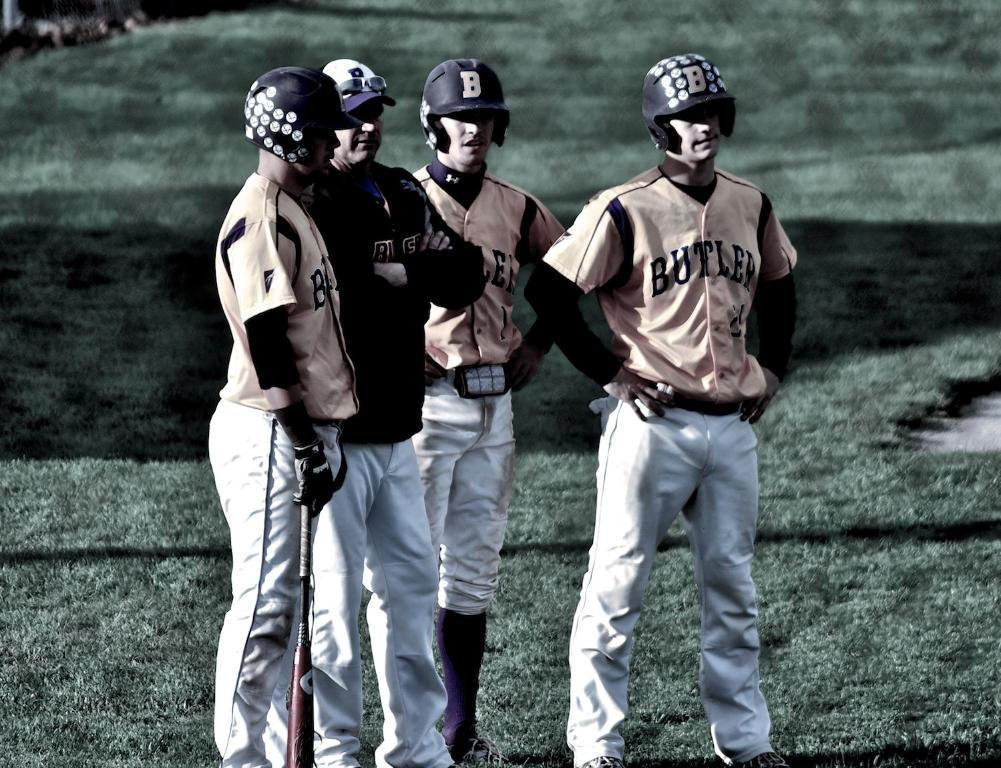What is happening in the image? There are persons standing in the image. What are the persons wearing? The persons are wearing clothes. Can you describe the position of the person on the left side of the image? The person on the left side is holding a bat with his hand. What type of substance is being used by the person on the right side of the image? There is no person on the right side of the image, and no substance is mentioned in the provided facts. --- Facts: 1. There is a car in the image. 2. The car is red. 3. The car has four wheels. 4. There is a person sitting in the car. 5. The person is wearing a hat. Absurd Topics: parrot, sand, mountain Conversation: What is the main subject of the image? The main subject of the image is a car. Can you describe the car's appearance? The car is red and has four wheels. Is there anyone inside the car? Yes, there is a person sitting in the car. What is the person wearing? The person is wearing a hat. Reasoning: Let's think step by step in order to produce the conversation. We start by identifying the main subject of the image, which is the car. Then, we describe the car's appearance, including its color and the number of wheels. Next, we mention the presence of a person inside the car and describe what they are wearing. Each question is designed to elicit a specific detail about the image that is known from the provided facts. Absurd Question/Answer: Can you tell me how many parrots are sitting on the sand in the image? There are no parrots or sand present in the image; it features a red car with a person wearing a hat inside. 